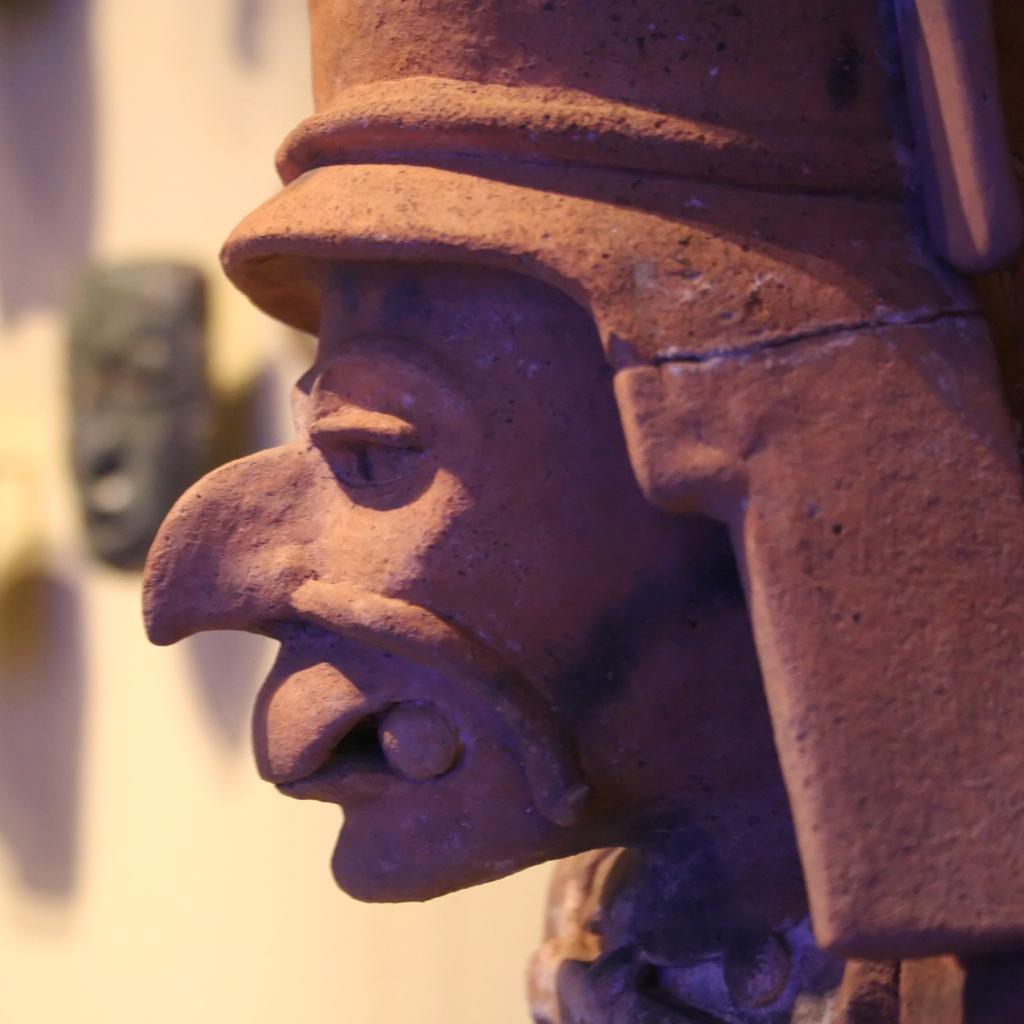What is the main subject of the image? There is a stone statue of a person's head in the image. What is the color of the statue? The statue is brown in color. What can be seen in the background of the image? There is a cream-colored surface and a black-colored object in the background of the image. Can you describe the horse that is jumping over the statue in the image? There is no horse or jumping activity present in the image; it features a stone statue of a person's head and background elements. 